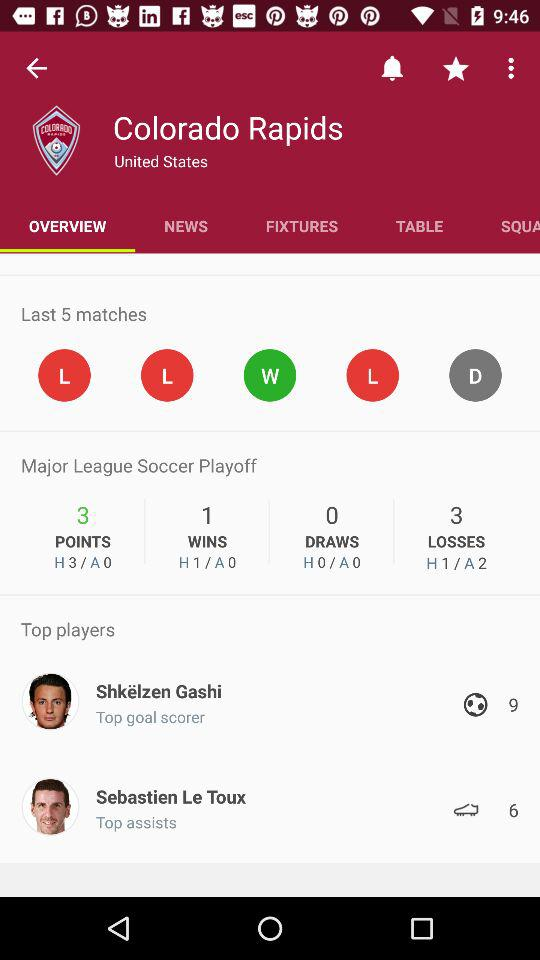How many more losses does Colorado Rapids have than wins?
Answer the question using a single word or phrase. 2 